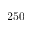Convert formula to latex. <formula><loc_0><loc_0><loc_500><loc_500>2 5 0</formula> 